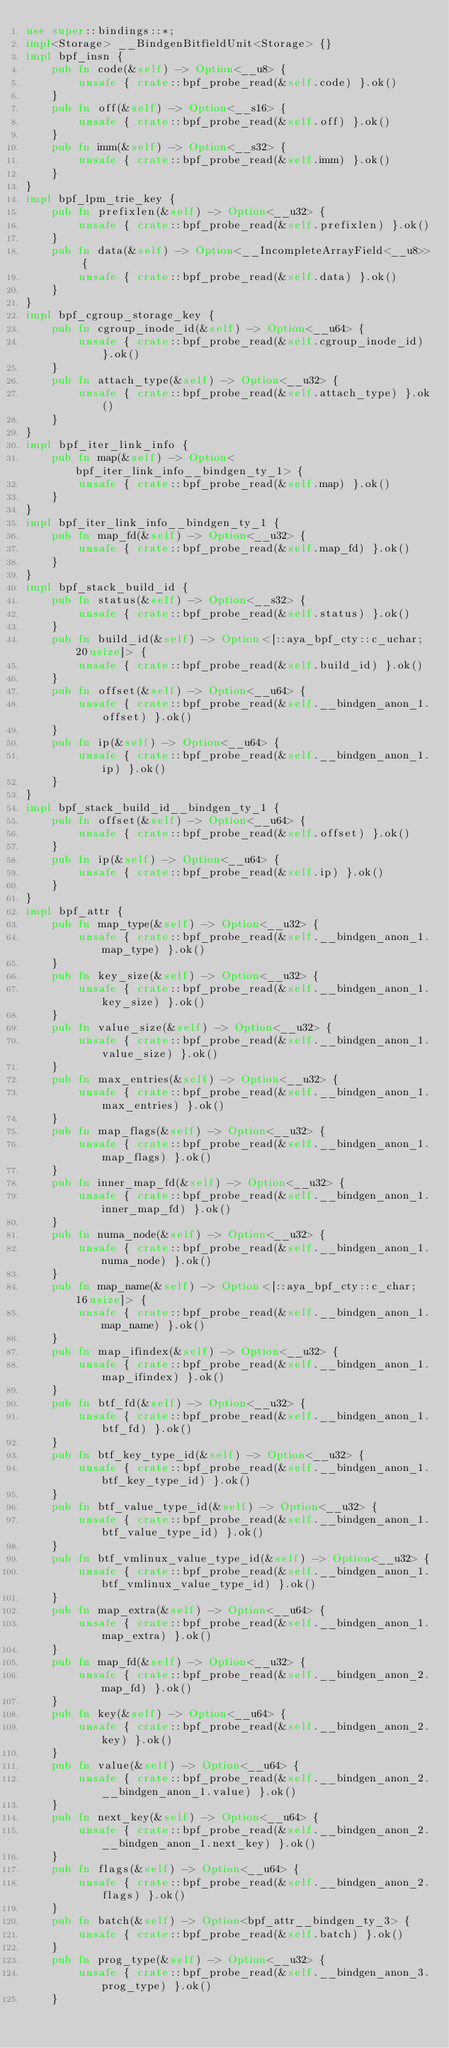<code> <loc_0><loc_0><loc_500><loc_500><_Rust_>use super::bindings::*;
impl<Storage> __BindgenBitfieldUnit<Storage> {}
impl bpf_insn {
    pub fn code(&self) -> Option<__u8> {
        unsafe { crate::bpf_probe_read(&self.code) }.ok()
    }
    pub fn off(&self) -> Option<__s16> {
        unsafe { crate::bpf_probe_read(&self.off) }.ok()
    }
    pub fn imm(&self) -> Option<__s32> {
        unsafe { crate::bpf_probe_read(&self.imm) }.ok()
    }
}
impl bpf_lpm_trie_key {
    pub fn prefixlen(&self) -> Option<__u32> {
        unsafe { crate::bpf_probe_read(&self.prefixlen) }.ok()
    }
    pub fn data(&self) -> Option<__IncompleteArrayField<__u8>> {
        unsafe { crate::bpf_probe_read(&self.data) }.ok()
    }
}
impl bpf_cgroup_storage_key {
    pub fn cgroup_inode_id(&self) -> Option<__u64> {
        unsafe { crate::bpf_probe_read(&self.cgroup_inode_id) }.ok()
    }
    pub fn attach_type(&self) -> Option<__u32> {
        unsafe { crate::bpf_probe_read(&self.attach_type) }.ok()
    }
}
impl bpf_iter_link_info {
    pub fn map(&self) -> Option<bpf_iter_link_info__bindgen_ty_1> {
        unsafe { crate::bpf_probe_read(&self.map) }.ok()
    }
}
impl bpf_iter_link_info__bindgen_ty_1 {
    pub fn map_fd(&self) -> Option<__u32> {
        unsafe { crate::bpf_probe_read(&self.map_fd) }.ok()
    }
}
impl bpf_stack_build_id {
    pub fn status(&self) -> Option<__s32> {
        unsafe { crate::bpf_probe_read(&self.status) }.ok()
    }
    pub fn build_id(&self) -> Option<[::aya_bpf_cty::c_uchar; 20usize]> {
        unsafe { crate::bpf_probe_read(&self.build_id) }.ok()
    }
    pub fn offset(&self) -> Option<__u64> {
        unsafe { crate::bpf_probe_read(&self.__bindgen_anon_1.offset) }.ok()
    }
    pub fn ip(&self) -> Option<__u64> {
        unsafe { crate::bpf_probe_read(&self.__bindgen_anon_1.ip) }.ok()
    }
}
impl bpf_stack_build_id__bindgen_ty_1 {
    pub fn offset(&self) -> Option<__u64> {
        unsafe { crate::bpf_probe_read(&self.offset) }.ok()
    }
    pub fn ip(&self) -> Option<__u64> {
        unsafe { crate::bpf_probe_read(&self.ip) }.ok()
    }
}
impl bpf_attr {
    pub fn map_type(&self) -> Option<__u32> {
        unsafe { crate::bpf_probe_read(&self.__bindgen_anon_1.map_type) }.ok()
    }
    pub fn key_size(&self) -> Option<__u32> {
        unsafe { crate::bpf_probe_read(&self.__bindgen_anon_1.key_size) }.ok()
    }
    pub fn value_size(&self) -> Option<__u32> {
        unsafe { crate::bpf_probe_read(&self.__bindgen_anon_1.value_size) }.ok()
    }
    pub fn max_entries(&self) -> Option<__u32> {
        unsafe { crate::bpf_probe_read(&self.__bindgen_anon_1.max_entries) }.ok()
    }
    pub fn map_flags(&self) -> Option<__u32> {
        unsafe { crate::bpf_probe_read(&self.__bindgen_anon_1.map_flags) }.ok()
    }
    pub fn inner_map_fd(&self) -> Option<__u32> {
        unsafe { crate::bpf_probe_read(&self.__bindgen_anon_1.inner_map_fd) }.ok()
    }
    pub fn numa_node(&self) -> Option<__u32> {
        unsafe { crate::bpf_probe_read(&self.__bindgen_anon_1.numa_node) }.ok()
    }
    pub fn map_name(&self) -> Option<[::aya_bpf_cty::c_char; 16usize]> {
        unsafe { crate::bpf_probe_read(&self.__bindgen_anon_1.map_name) }.ok()
    }
    pub fn map_ifindex(&self) -> Option<__u32> {
        unsafe { crate::bpf_probe_read(&self.__bindgen_anon_1.map_ifindex) }.ok()
    }
    pub fn btf_fd(&self) -> Option<__u32> {
        unsafe { crate::bpf_probe_read(&self.__bindgen_anon_1.btf_fd) }.ok()
    }
    pub fn btf_key_type_id(&self) -> Option<__u32> {
        unsafe { crate::bpf_probe_read(&self.__bindgen_anon_1.btf_key_type_id) }.ok()
    }
    pub fn btf_value_type_id(&self) -> Option<__u32> {
        unsafe { crate::bpf_probe_read(&self.__bindgen_anon_1.btf_value_type_id) }.ok()
    }
    pub fn btf_vmlinux_value_type_id(&self) -> Option<__u32> {
        unsafe { crate::bpf_probe_read(&self.__bindgen_anon_1.btf_vmlinux_value_type_id) }.ok()
    }
    pub fn map_extra(&self) -> Option<__u64> {
        unsafe { crate::bpf_probe_read(&self.__bindgen_anon_1.map_extra) }.ok()
    }
    pub fn map_fd(&self) -> Option<__u32> {
        unsafe { crate::bpf_probe_read(&self.__bindgen_anon_2.map_fd) }.ok()
    }
    pub fn key(&self) -> Option<__u64> {
        unsafe { crate::bpf_probe_read(&self.__bindgen_anon_2.key) }.ok()
    }
    pub fn value(&self) -> Option<__u64> {
        unsafe { crate::bpf_probe_read(&self.__bindgen_anon_2.__bindgen_anon_1.value) }.ok()
    }
    pub fn next_key(&self) -> Option<__u64> {
        unsafe { crate::bpf_probe_read(&self.__bindgen_anon_2.__bindgen_anon_1.next_key) }.ok()
    }
    pub fn flags(&self) -> Option<__u64> {
        unsafe { crate::bpf_probe_read(&self.__bindgen_anon_2.flags) }.ok()
    }
    pub fn batch(&self) -> Option<bpf_attr__bindgen_ty_3> {
        unsafe { crate::bpf_probe_read(&self.batch) }.ok()
    }
    pub fn prog_type(&self) -> Option<__u32> {
        unsafe { crate::bpf_probe_read(&self.__bindgen_anon_3.prog_type) }.ok()
    }</code> 